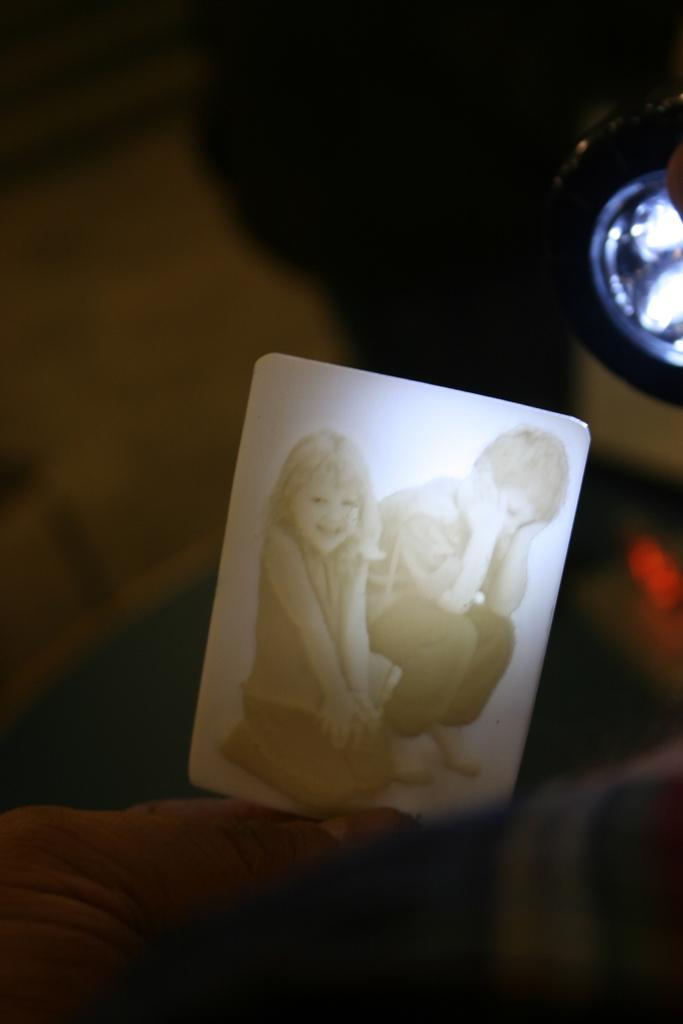What is the lighting condition in the image? The image is taken in the dark. What object with a rectangular shape can be seen in the image? There is a rectangular device in the image. What is depicted on the rectangular device? The sketch of two kids, a girl and a boy, is present on the rectangular device. Can you see any planes flying in the image? There are no planes visible in the image; it features a rectangular device with a sketch of two kids. Is there any indication of winter in the image? There is no indication of winter in the image; the focus is on the rectangular device and the sketch of two kids. 